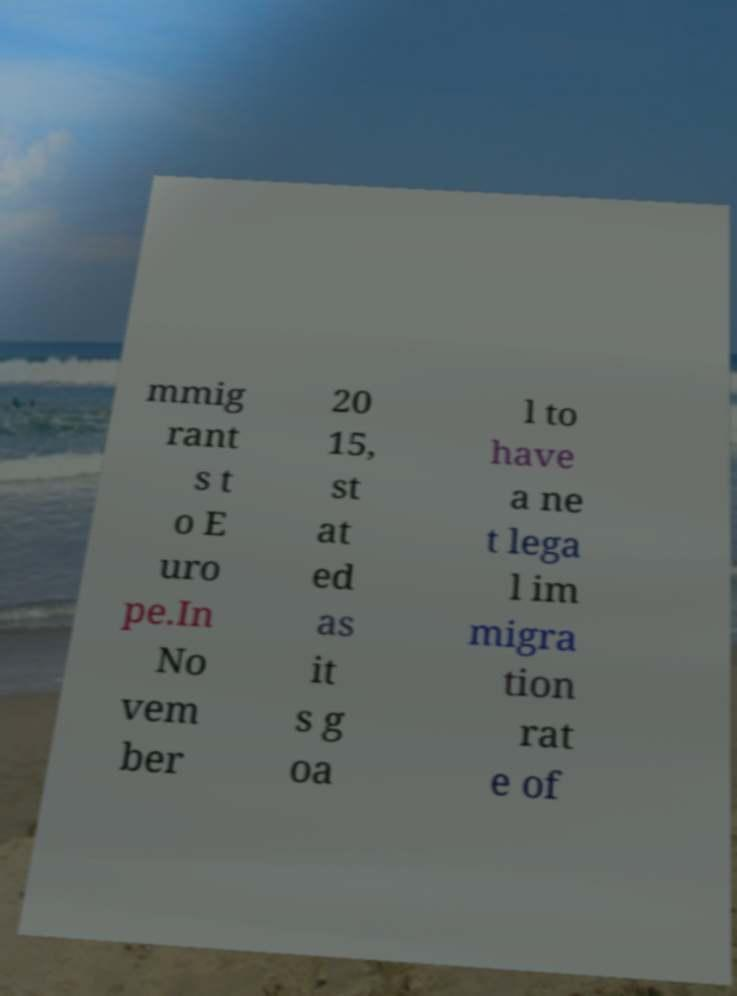Can you read and provide the text displayed in the image?This photo seems to have some interesting text. Can you extract and type it out for me? mmig rant s t o E uro pe.In No vem ber 20 15, st at ed as it s g oa l to have a ne t lega l im migra tion rat e of 